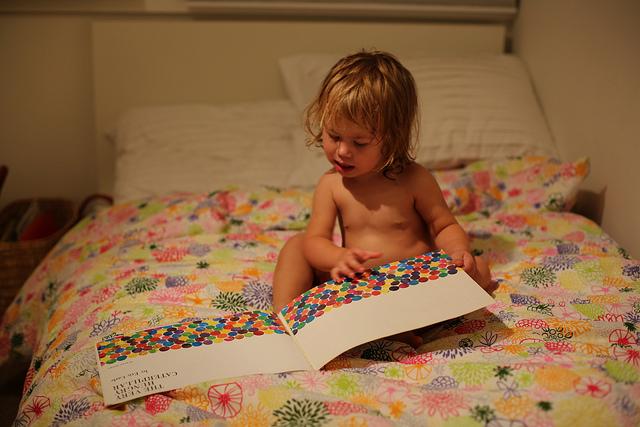Is the child dressed for the day?
Keep it brief. No. Is the little girls bedroom?
Write a very short answer. Yes. Is there a black headband on the bed?
Be succinct. No. What is sitting on the bed?
Short answer required. Child. Why didn't the toddler sleep in her pajamas?
Give a very brief answer. Too hot. Is the child reading a book?
Short answer required. Yes. How many pillows are there?
Quick response, please. 2. 